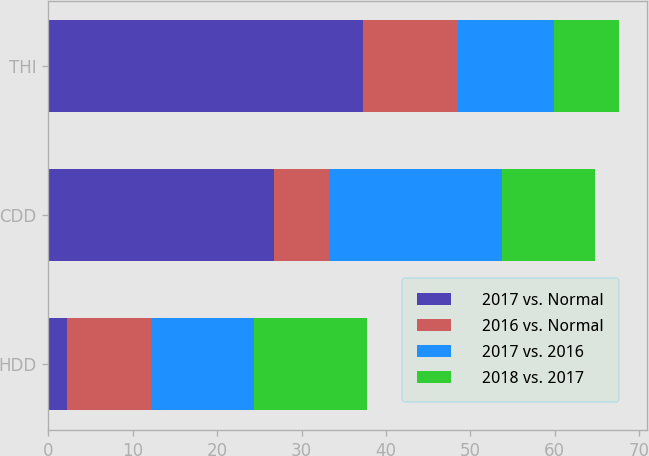Convert chart. <chart><loc_0><loc_0><loc_500><loc_500><stacked_bar_chart><ecel><fcel>HDD<fcel>CDD<fcel>THI<nl><fcel>2017 vs. Normal<fcel>2.2<fcel>26.7<fcel>37.3<nl><fcel>2016 vs. Normal<fcel>10<fcel>6.5<fcel>11.3<nl><fcel>2017 vs. 2016<fcel>12.2<fcel>20.5<fcel>11.3<nl><fcel>2018 vs. 2017<fcel>13.4<fcel>11.1<fcel>7.7<nl></chart> 